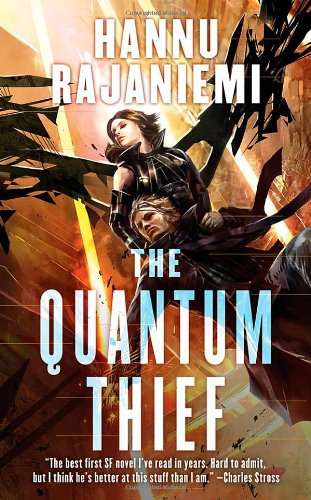Can you describe the setting of the book depicted in the image? The setting of 'The Quantum Thief' is predominantly within the Oubliette, a moving city on Mars, which provides a dynamic and layered backdrop for its story of theft, deception, and the search for freedom. 